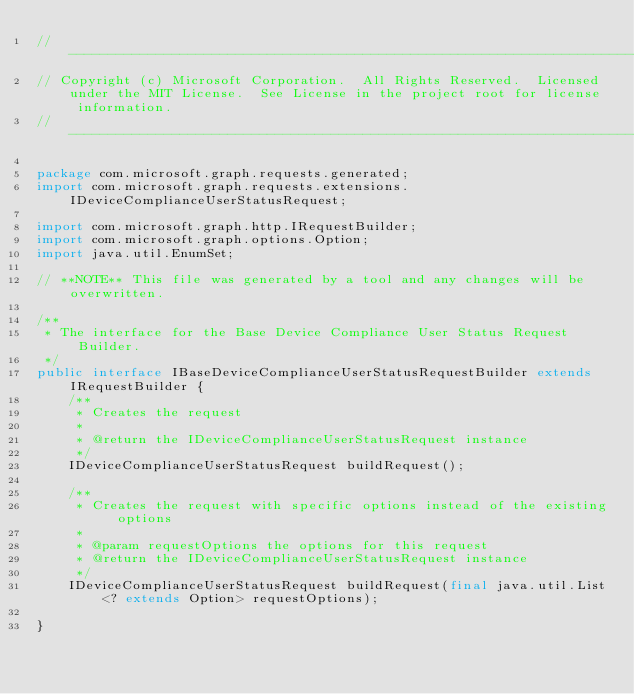<code> <loc_0><loc_0><loc_500><loc_500><_Java_>// ------------------------------------------------------------------------------
// Copyright (c) Microsoft Corporation.  All Rights Reserved.  Licensed under the MIT License.  See License in the project root for license information.
// ------------------------------------------------------------------------------

package com.microsoft.graph.requests.generated;
import com.microsoft.graph.requests.extensions.IDeviceComplianceUserStatusRequest;

import com.microsoft.graph.http.IRequestBuilder;
import com.microsoft.graph.options.Option;
import java.util.EnumSet;

// **NOTE** This file was generated by a tool and any changes will be overwritten.

/**
 * The interface for the Base Device Compliance User Status Request Builder.
 */
public interface IBaseDeviceComplianceUserStatusRequestBuilder extends IRequestBuilder {
    /**
     * Creates the request
     *
     * @return the IDeviceComplianceUserStatusRequest instance
     */
    IDeviceComplianceUserStatusRequest buildRequest();

    /**
     * Creates the request with specific options instead of the existing options
     *
     * @param requestOptions the options for this request
     * @return the IDeviceComplianceUserStatusRequest instance
     */
    IDeviceComplianceUserStatusRequest buildRequest(final java.util.List<? extends Option> requestOptions);

}
</code> 